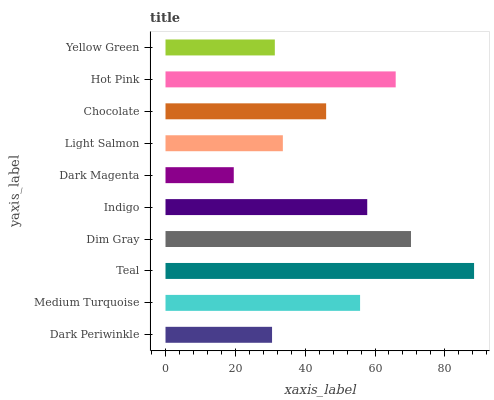Is Dark Magenta the minimum?
Answer yes or no. Yes. Is Teal the maximum?
Answer yes or no. Yes. Is Medium Turquoise the minimum?
Answer yes or no. No. Is Medium Turquoise the maximum?
Answer yes or no. No. Is Medium Turquoise greater than Dark Periwinkle?
Answer yes or no. Yes. Is Dark Periwinkle less than Medium Turquoise?
Answer yes or no. Yes. Is Dark Periwinkle greater than Medium Turquoise?
Answer yes or no. No. Is Medium Turquoise less than Dark Periwinkle?
Answer yes or no. No. Is Medium Turquoise the high median?
Answer yes or no. Yes. Is Chocolate the low median?
Answer yes or no. Yes. Is Dark Periwinkle the high median?
Answer yes or no. No. Is Dark Magenta the low median?
Answer yes or no. No. 